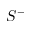<formula> <loc_0><loc_0><loc_500><loc_500>S ^ { - }</formula> 